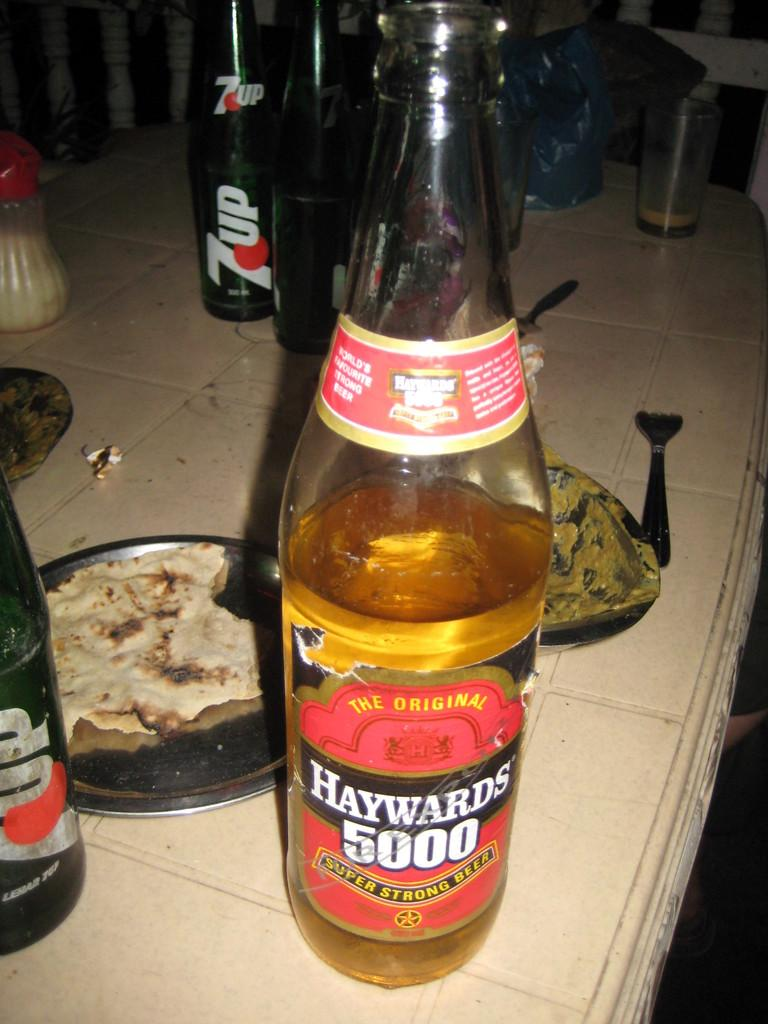<image>
Present a compact description of the photo's key features. A bottle of wine with Haywards 5000 on the bottle. 